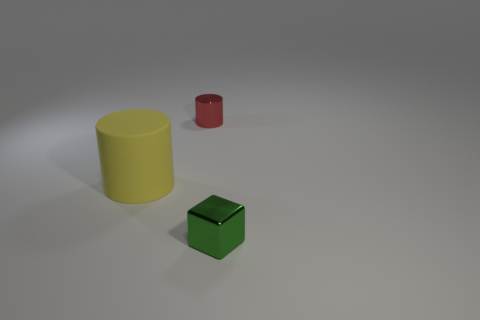Is the texture of the yellow object different from that of the green one? Yes, the yellow cylinder has a matte finish, which gives it a non-reflective, smooth appearance. On the other hand, the green object, which is a cube, has a slightly shiny surface that reflects light, indicating that its texture is somewhat glossier. 